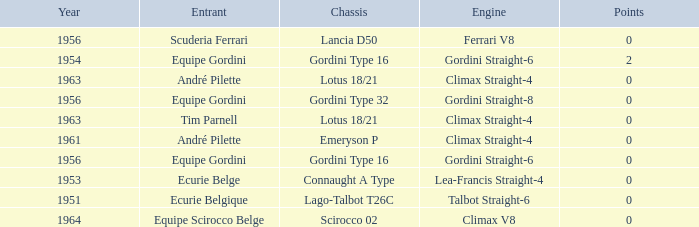Who used Gordini Straight-6 in 1956? Equipe Gordini. Parse the full table. {'header': ['Year', 'Entrant', 'Chassis', 'Engine', 'Points'], 'rows': [['1956', 'Scuderia Ferrari', 'Lancia D50', 'Ferrari V8', '0'], ['1954', 'Equipe Gordini', 'Gordini Type 16', 'Gordini Straight-6', '2'], ['1963', 'André Pilette', 'Lotus 18/21', 'Climax Straight-4', '0'], ['1956', 'Equipe Gordini', 'Gordini Type 32', 'Gordini Straight-8', '0'], ['1963', 'Tim Parnell', 'Lotus 18/21', 'Climax Straight-4', '0'], ['1961', 'André Pilette', 'Emeryson P', 'Climax Straight-4', '0'], ['1956', 'Equipe Gordini', 'Gordini Type 16', 'Gordini Straight-6', '0'], ['1953', 'Ecurie Belge', 'Connaught A Type', 'Lea-Francis Straight-4', '0'], ['1951', 'Ecurie Belgique', 'Lago-Talbot T26C', 'Talbot Straight-6', '0'], ['1964', 'Equipe Scirocco Belge', 'Scirocco 02', 'Climax V8', '0']]} 